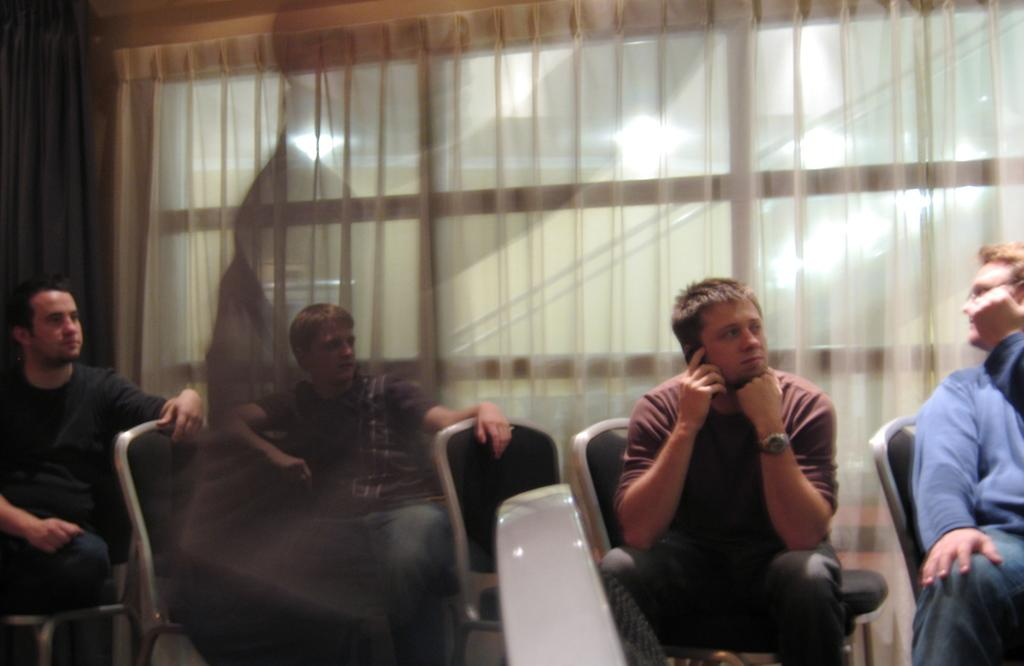How many persons are in the image? There is a group of persons in the image. What are the persons in the image doing? The persons are sitting on chairs. Can you describe the person in the middle of the image? The person in the middle is wearing a red color shirt and is answering the phone. What type of park can be seen in the background of the image? There is no park visible in the image; it features a group of persons sitting on chairs. How many tents are set up in the image? There are no tents present in the image. 